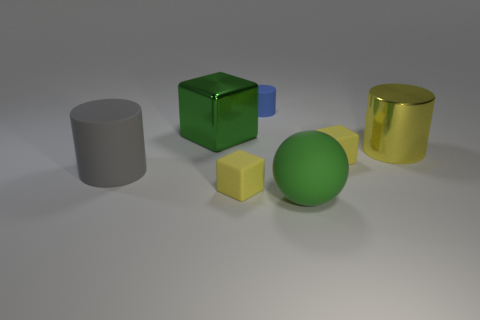Subtract all brown spheres. How many yellow blocks are left? 2 Add 3 tiny red cylinders. How many objects exist? 10 Subtract all big cylinders. How many cylinders are left? 1 Subtract 1 blocks. How many blocks are left? 2 Subtract all spheres. How many objects are left? 6 Subtract all gray blocks. Subtract all green cylinders. How many blocks are left? 3 Subtract 0 blue balls. How many objects are left? 7 Subtract all cyan cubes. Subtract all small yellow rubber blocks. How many objects are left? 5 Add 7 large blocks. How many large blocks are left? 8 Add 6 large green metallic objects. How many large green metallic objects exist? 7 